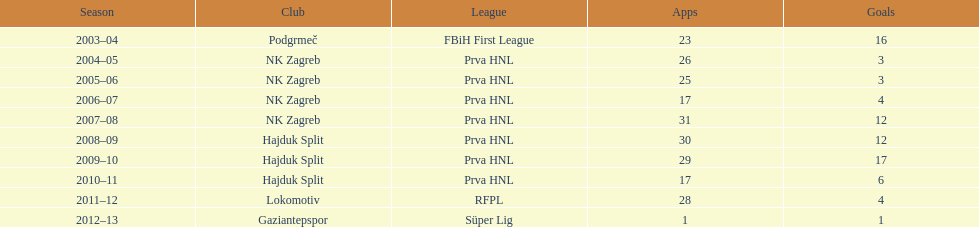Did ibricic score more or less goals in his 3 seasons with hajduk split when compared to his 4 seasons with nk zagreb? More. 